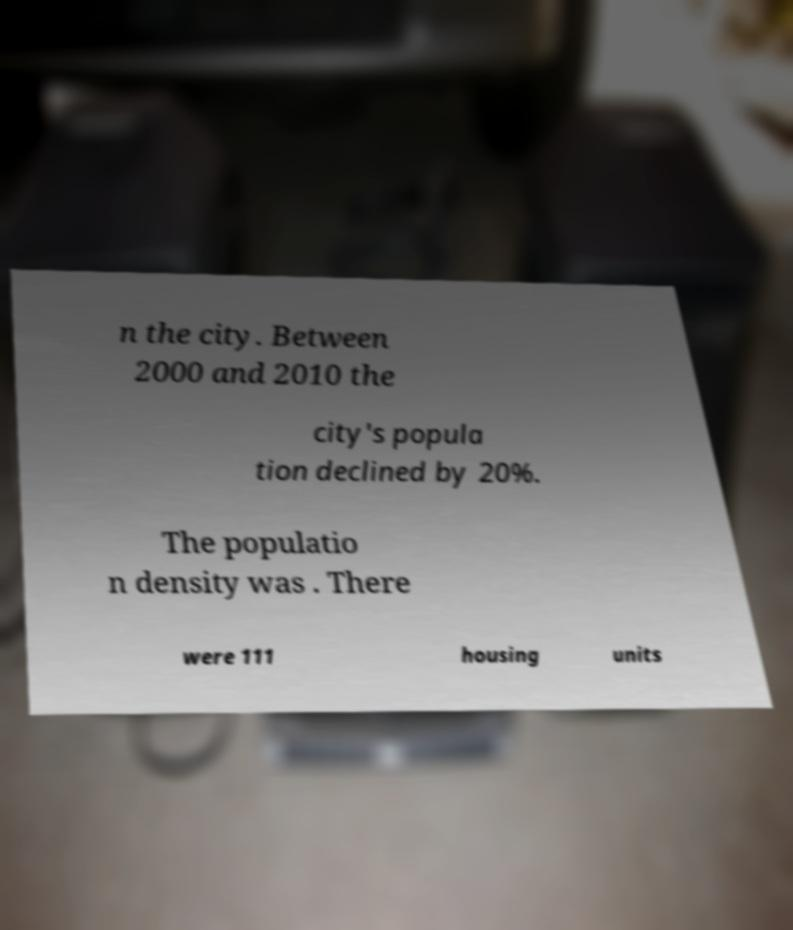Please identify and transcribe the text found in this image. n the city. Between 2000 and 2010 the city's popula tion declined by 20%. The populatio n density was . There were 111 housing units 